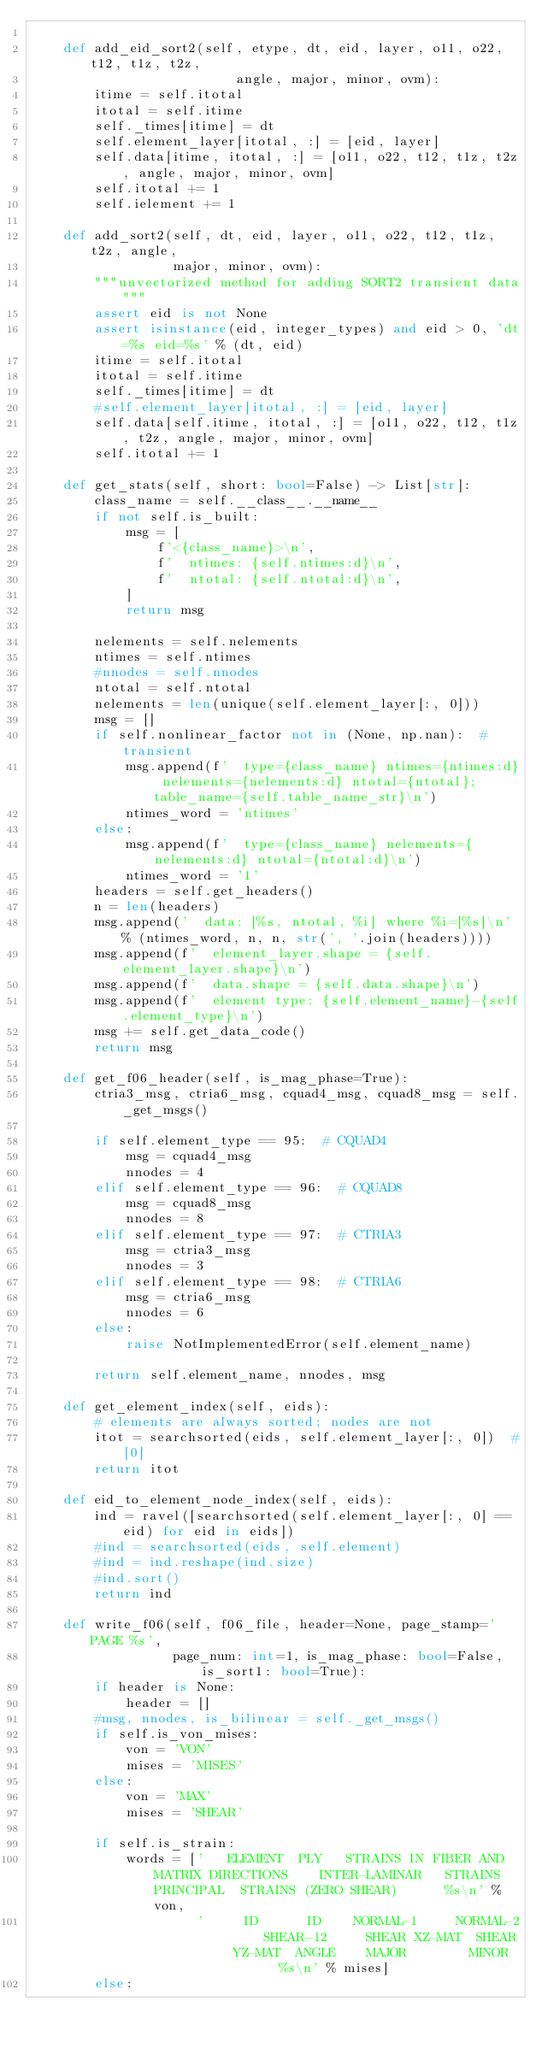<code> <loc_0><loc_0><loc_500><loc_500><_Python_>
    def add_eid_sort2(self, etype, dt, eid, layer, o11, o22, t12, t1z, t2z,
                          angle, major, minor, ovm):
        itime = self.itotal
        itotal = self.itime
        self._times[itime] = dt
        self.element_layer[itotal, :] = [eid, layer]
        self.data[itime, itotal, :] = [o11, o22, t12, t1z, t2z, angle, major, minor, ovm]
        self.itotal += 1
        self.ielement += 1

    def add_sort2(self, dt, eid, layer, o11, o22, t12, t1z, t2z, angle,
                  major, minor, ovm):
        """unvectorized method for adding SORT2 transient data"""
        assert eid is not None
        assert isinstance(eid, integer_types) and eid > 0, 'dt=%s eid=%s' % (dt, eid)
        itime = self.itotal
        itotal = self.itime
        self._times[itime] = dt
        #self.element_layer[itotal, :] = [eid, layer]
        self.data[self.itime, itotal, :] = [o11, o22, t12, t1z, t2z, angle, major, minor, ovm]
        self.itotal += 1

    def get_stats(self, short: bool=False) -> List[str]:
        class_name = self.__class__.__name__
        if not self.is_built:
            msg = [
                f'<{class_name}>\n',
                f'  ntimes: {self.ntimes:d}\n',
                f'  ntotal: {self.ntotal:d}\n',
            ]
            return msg

        nelements = self.nelements
        ntimes = self.ntimes
        #nnodes = self.nnodes
        ntotal = self.ntotal
        nelements = len(unique(self.element_layer[:, 0]))
        msg = []
        if self.nonlinear_factor not in (None, np.nan):  # transient
            msg.append(f'  type={class_name} ntimes={ntimes:d} nelements={nelements:d} ntotal={ntotal}; table_name={self.table_name_str}\n')
            ntimes_word = 'ntimes'
        else:
            msg.append(f'  type={class_name} nelements={nelements:d} ntotal={ntotal:d}\n')
            ntimes_word = '1'
        headers = self.get_headers()
        n = len(headers)
        msg.append('  data: [%s, ntotal, %i] where %i=[%s]\n' % (ntimes_word, n, n, str(', '.join(headers))))
        msg.append(f'  element_layer.shape = {self.element_layer.shape}\n')
        msg.append(f'  data.shape = {self.data.shape}\n')
        msg.append(f'  element type: {self.element_name}-{self.element_type}\n')
        msg += self.get_data_code()
        return msg

    def get_f06_header(self, is_mag_phase=True):
        ctria3_msg, ctria6_msg, cquad4_msg, cquad8_msg = self._get_msgs()

        if self.element_type == 95:  # CQUAD4
            msg = cquad4_msg
            nnodes = 4
        elif self.element_type == 96:  # CQUAD8
            msg = cquad8_msg
            nnodes = 8
        elif self.element_type == 97:  # CTRIA3
            msg = ctria3_msg
            nnodes = 3
        elif self.element_type == 98:  # CTRIA6
            msg = ctria6_msg
            nnodes = 6
        else:
            raise NotImplementedError(self.element_name)

        return self.element_name, nnodes, msg

    def get_element_index(self, eids):
        # elements are always sorted; nodes are not
        itot = searchsorted(eids, self.element_layer[:, 0])  #[0]
        return itot

    def eid_to_element_node_index(self, eids):
        ind = ravel([searchsorted(self.element_layer[:, 0] == eid) for eid in eids])
        #ind = searchsorted(eids, self.element)
        #ind = ind.reshape(ind.size)
        #ind.sort()
        return ind

    def write_f06(self, f06_file, header=None, page_stamp='PAGE %s',
                  page_num: int=1, is_mag_phase: bool=False, is_sort1: bool=True):
        if header is None:
            header = []
        #msg, nnodes, is_bilinear = self._get_msgs()
        if self.is_von_mises:
            von = 'VON'
            mises = 'MISES'
        else:
            von = 'MAX'
            mises = 'SHEAR'

        if self.is_strain:
            words = ['   ELEMENT  PLY   STRAINS IN FIBER AND MATRIX DIRECTIONS    INTER-LAMINAR   STRAINS  PRINCIPAL  STRAINS (ZERO SHEAR)      %s\n' % von,
                     '     ID      ID    NORMAL-1     NORMAL-2     SHEAR-12     SHEAR XZ-MAT  SHEAR YZ-MAT  ANGLE    MAJOR        MINOR        %s\n' % mises]
        else:</code> 